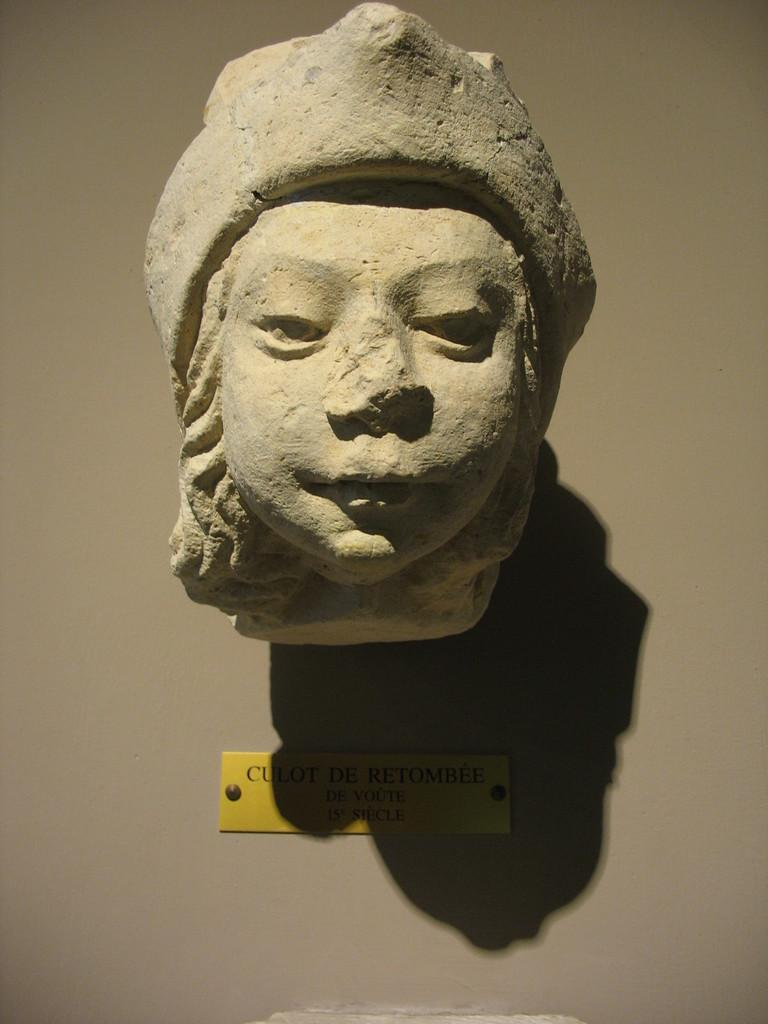What is the main subject in the center of the image? There is a lady statue in the center of the image. What type of insect can be seen crawling on the lady statue in the image? There is no insect present on the lady statue in the image. How many pigs are visible near the lady statue in the image? There are no pigs present near the lady statue in the image. 